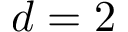Convert formula to latex. <formula><loc_0><loc_0><loc_500><loc_500>d = 2</formula> 